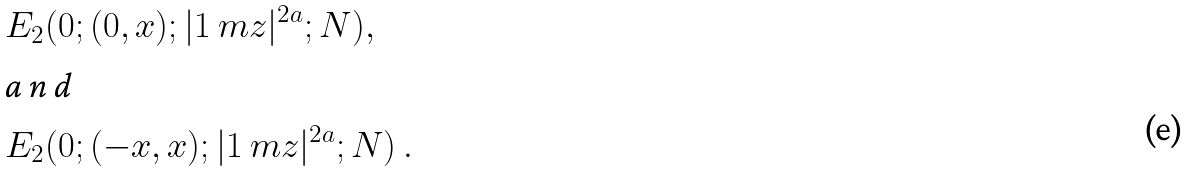Convert formula to latex. <formula><loc_0><loc_0><loc_500><loc_500>& E _ { 2 } ( 0 ; ( 0 , x ) ; | 1 \ m z | ^ { 2 a } ; N ) , \\ \intertext { a n d } & E _ { 2 } ( 0 ; ( - x , x ) ; | 1 \ m z | ^ { 2 a } ; N ) \ .</formula> 